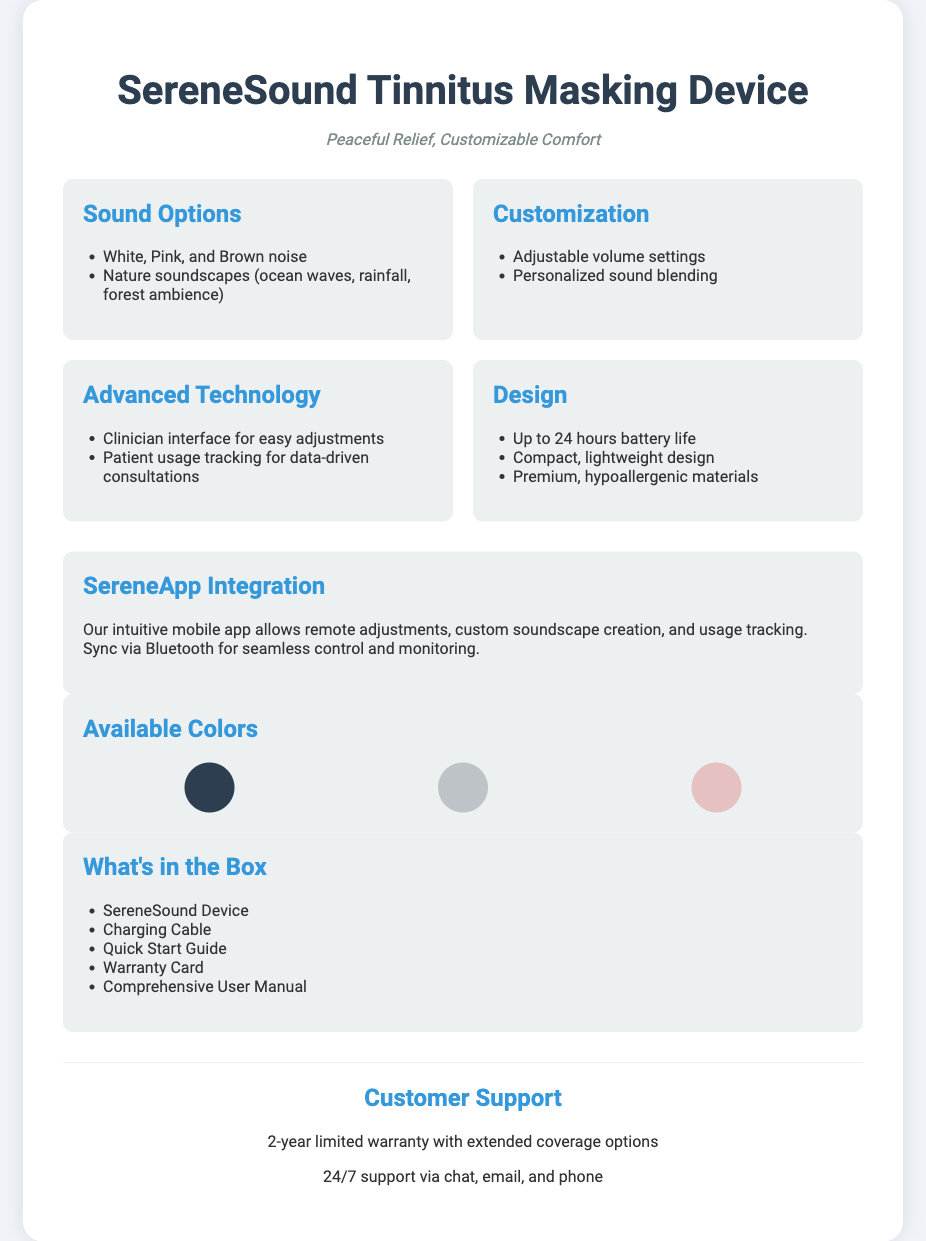What types of sound options does the device offer? The sound options include White, Pink, and Brown noise, as well as nature soundscapes like ocean waves and rainfall.
Answer: White, Pink, and Brown noise; Nature soundscapes What is the battery life of the SereneSound device? The document states that the device has a battery life of up to 24 hours.
Answer: 24 hours How can users customize the sound settings? Users can adjust volume settings and personalize sound blending according to the document.
Answer: Adjustable volume settings; Personalized sound blending What is the purpose of the SereneApp? The SereneApp allows remote adjustments, custom soundscape creation, and usage tracking while syncing via Bluetooth.
Answer: Remote adjustments, custom soundscape creation, usage tracking What components are included in the packaging? The packaging includes the SereneSound Device, Charging Cable, Quick Start Guide, Warranty Card, and Comprehensive User Manual.
Answer: SereneSound Device, Charging Cable, Quick Start Guide, Warranty Card, Comprehensive User Manual What customer support options are available? The document mentions 24/7 support via chat, email, and phone, along with a 2-year limited warranty.
Answer: 24/7 support; 2-year limited warranty How is the design of the device described? The design is described as compact, lightweight, and made from premium, hypoallergenic materials.
Answer: Compact, lightweight design; Premium, hypoallergenic materials What colors are available for the device? The available colors for the device are Matte Black, Silver, and Rose Gold.
Answer: Matte Black, Silver, Rose Gold 